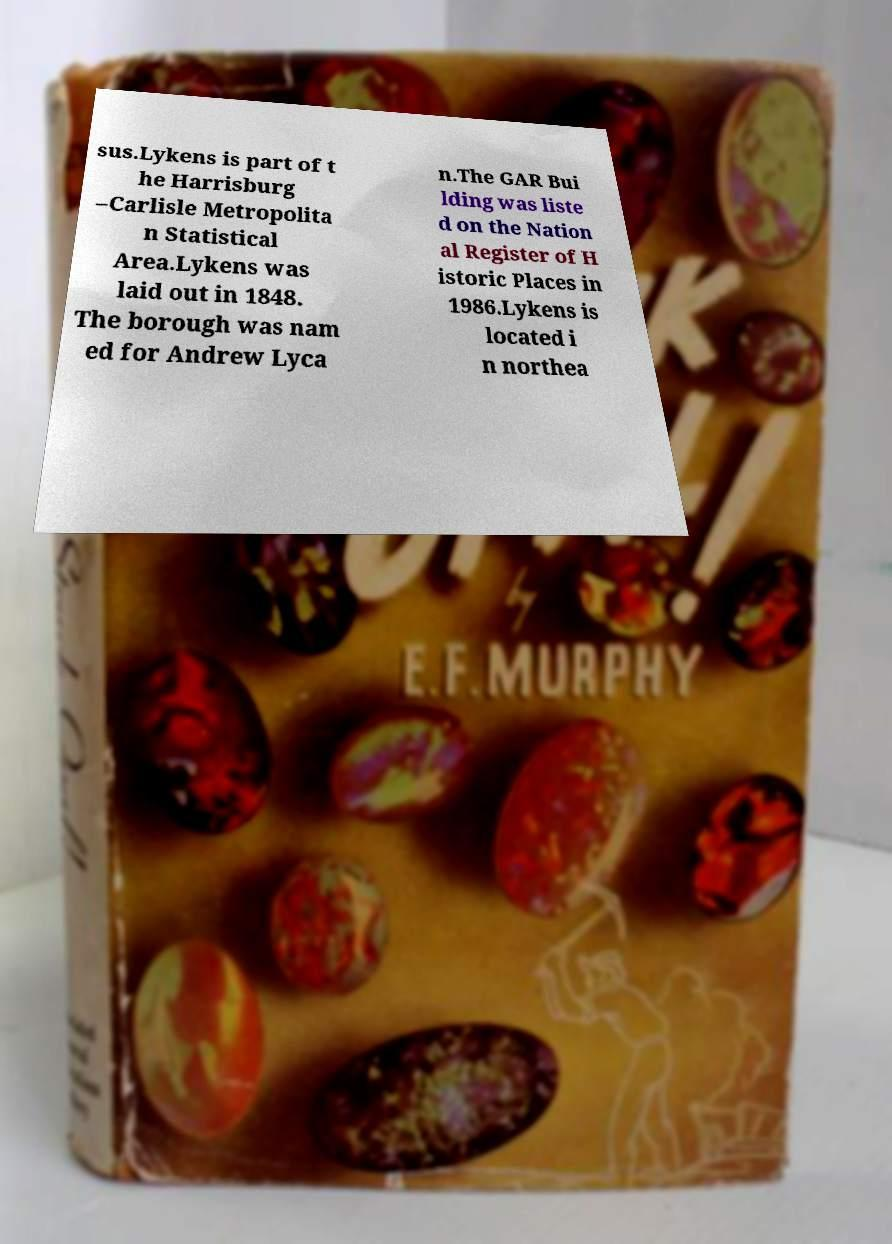There's text embedded in this image that I need extracted. Can you transcribe it verbatim? sus.Lykens is part of t he Harrisburg –Carlisle Metropolita n Statistical Area.Lykens was laid out in 1848. The borough was nam ed for Andrew Lyca n.The GAR Bui lding was liste d on the Nation al Register of H istoric Places in 1986.Lykens is located i n northea 